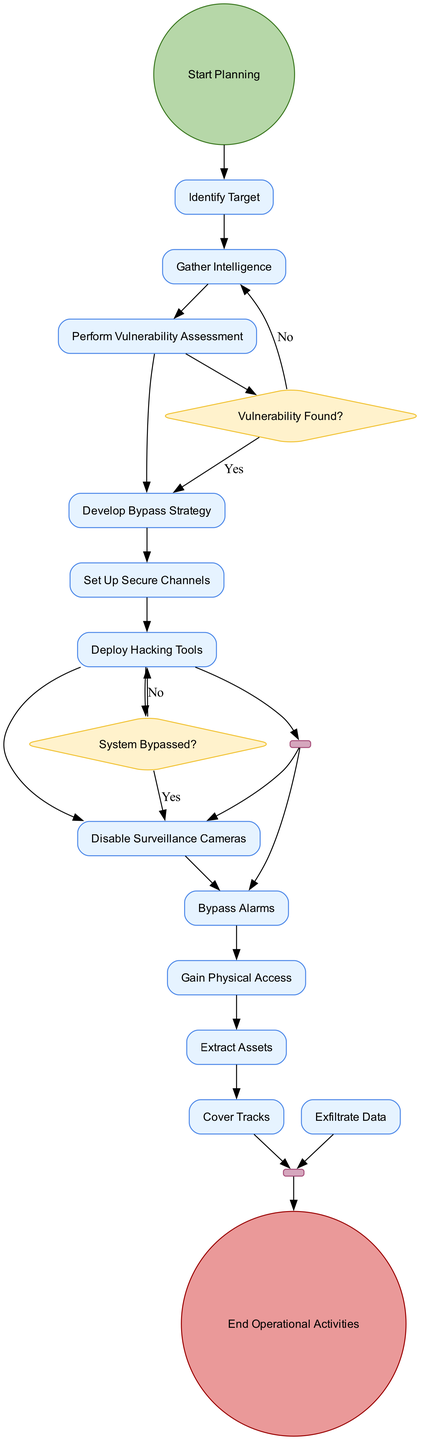What is the starting point of the process? The starting point of the process is indicated as a node labeled "Start Planning." This is the first activity from which all subsequent actions flow.
Answer: Start Planning How many activities are there in total? The diagram lists 12 distinct activities, starting from "Identify Target" through to "Cover Tracks." Counting all these nodes gives a total of 12 activities.
Answer: 12 Which activity follows "Gather Intelligence"? In the flow of the diagram, "Perform Vulnerability Assessment" directly follows the "Gather Intelligence" activity, indicating the next step after intelligence gathering.
Answer: Perform Vulnerability Assessment What decision follows "Perform Vulnerability Assessment"? After "Perform Vulnerability Assessment," the next action is a decision node labeled "Vulnerability Found?", determining whether vulnerabilities exist in the system.
Answer: Vulnerability Found? What happens if the decision "Vulnerability Found?" is answered "No"? If the decision "Vulnerability Found?" is answered "No," the flow leads back to "Gather Intelligence," suggesting the need for more information gathering before proceeding.
Answer: Gather Intelligence What two activities are handled concurrently? The split in the diagram indicates that "Disable Surveillance Cameras" and "Bypass Alarms" are managed simultaneously, as represented by the concurrent handling node labeled "Concurrently Disable and Bypass."
Answer: Disable Surveillance Cameras and Bypass Alarms Which activities are merged before ending the process? The final activities "Cover Tracks" and "Exfiltrate Data" are merged before concluding the process. This indicates that both actions must be completed before the hacking operation ends.
Answer: Cover Tracks and Exfiltrate Data What is the last activity before ending the operational activities? The last activity before reaching the end node is labeled "Cover Tracks," which is essential for ensuring that no evidence is left behind before concluding all operational activities.
Answer: Cover Tracks What is the end point of the process? The end point of the process is indicated as "End Operational Activities," which marks the conclusion of all hacking efforts and the securing of any acquired assets.
Answer: End Operational Activities 